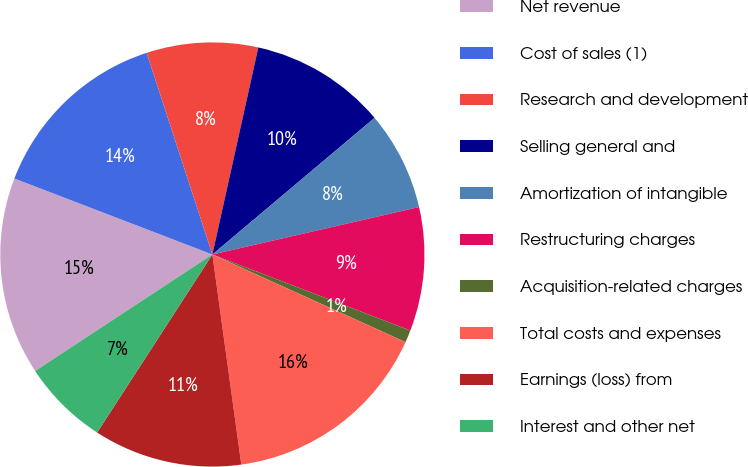<chart> <loc_0><loc_0><loc_500><loc_500><pie_chart><fcel>Net revenue<fcel>Cost of sales (1)<fcel>Research and development<fcel>Selling general and<fcel>Amortization of intangible<fcel>Restructuring charges<fcel>Acquisition-related charges<fcel>Total costs and expenses<fcel>Earnings (loss) from<fcel>Interest and other net<nl><fcel>15.09%<fcel>14.15%<fcel>8.49%<fcel>10.38%<fcel>7.55%<fcel>9.43%<fcel>0.94%<fcel>16.04%<fcel>11.32%<fcel>6.6%<nl></chart> 